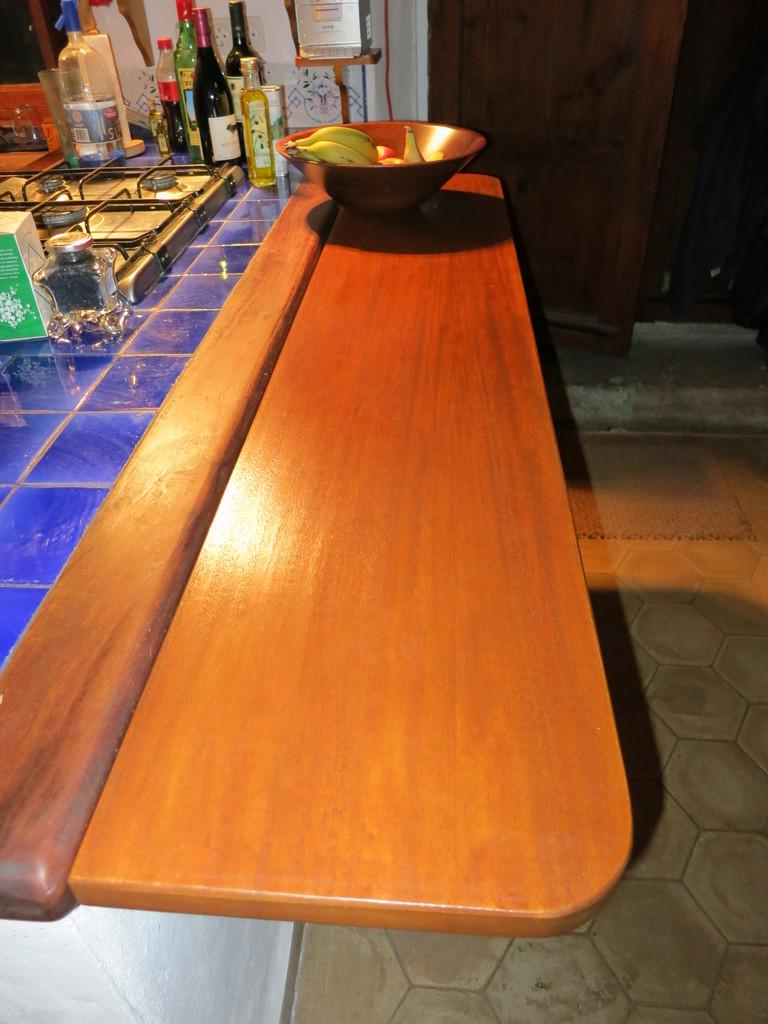What type of surface is visible in the image? There is a wooden countertop in the image. What cooking appliance is on the countertop? There is a gas stove on the countertop. What type of beverage containers are in the image? There are wine bottles in the image. What type of food is in the bowl in the image? There is a bowl with fruits in the image. How many snails can be seen crawling on the wooden countertop in the image? There are no snails visible on the wooden countertop in the image. 